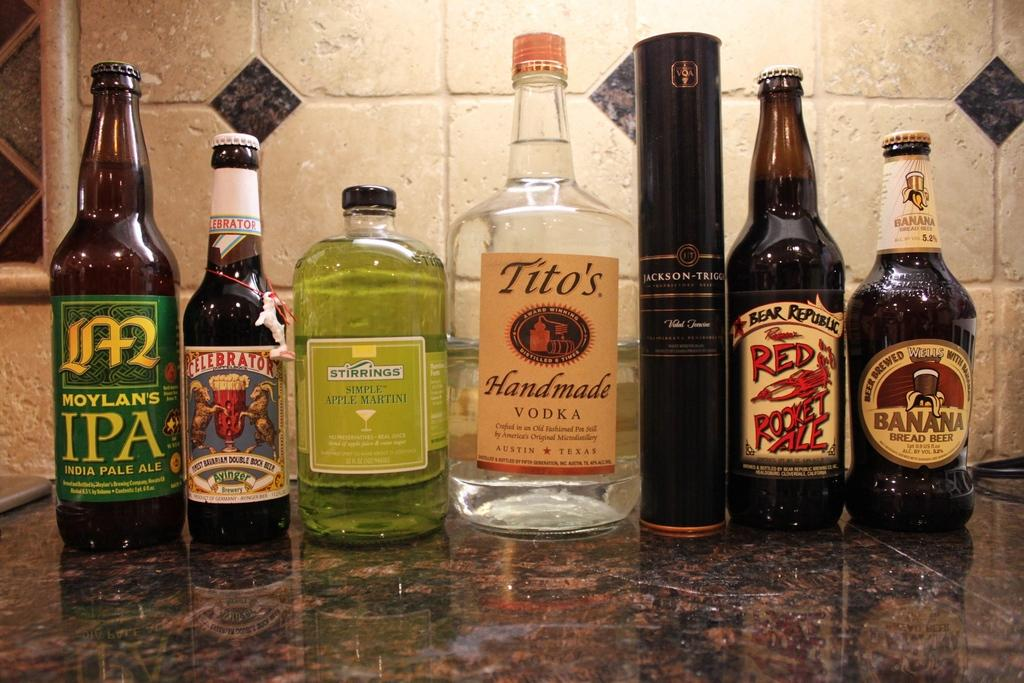What objects are present in the image? There are bottles in the image. Can you describe the bottles in the image? Unfortunately, the provided facts do not include any details about the bottles. Are there any other objects or figures in the image besides the bottles? The provided facts do not mention any other objects or figures in the image. How many giraffes are visible in the image? There are no giraffes present in the image; it only features bottles. 